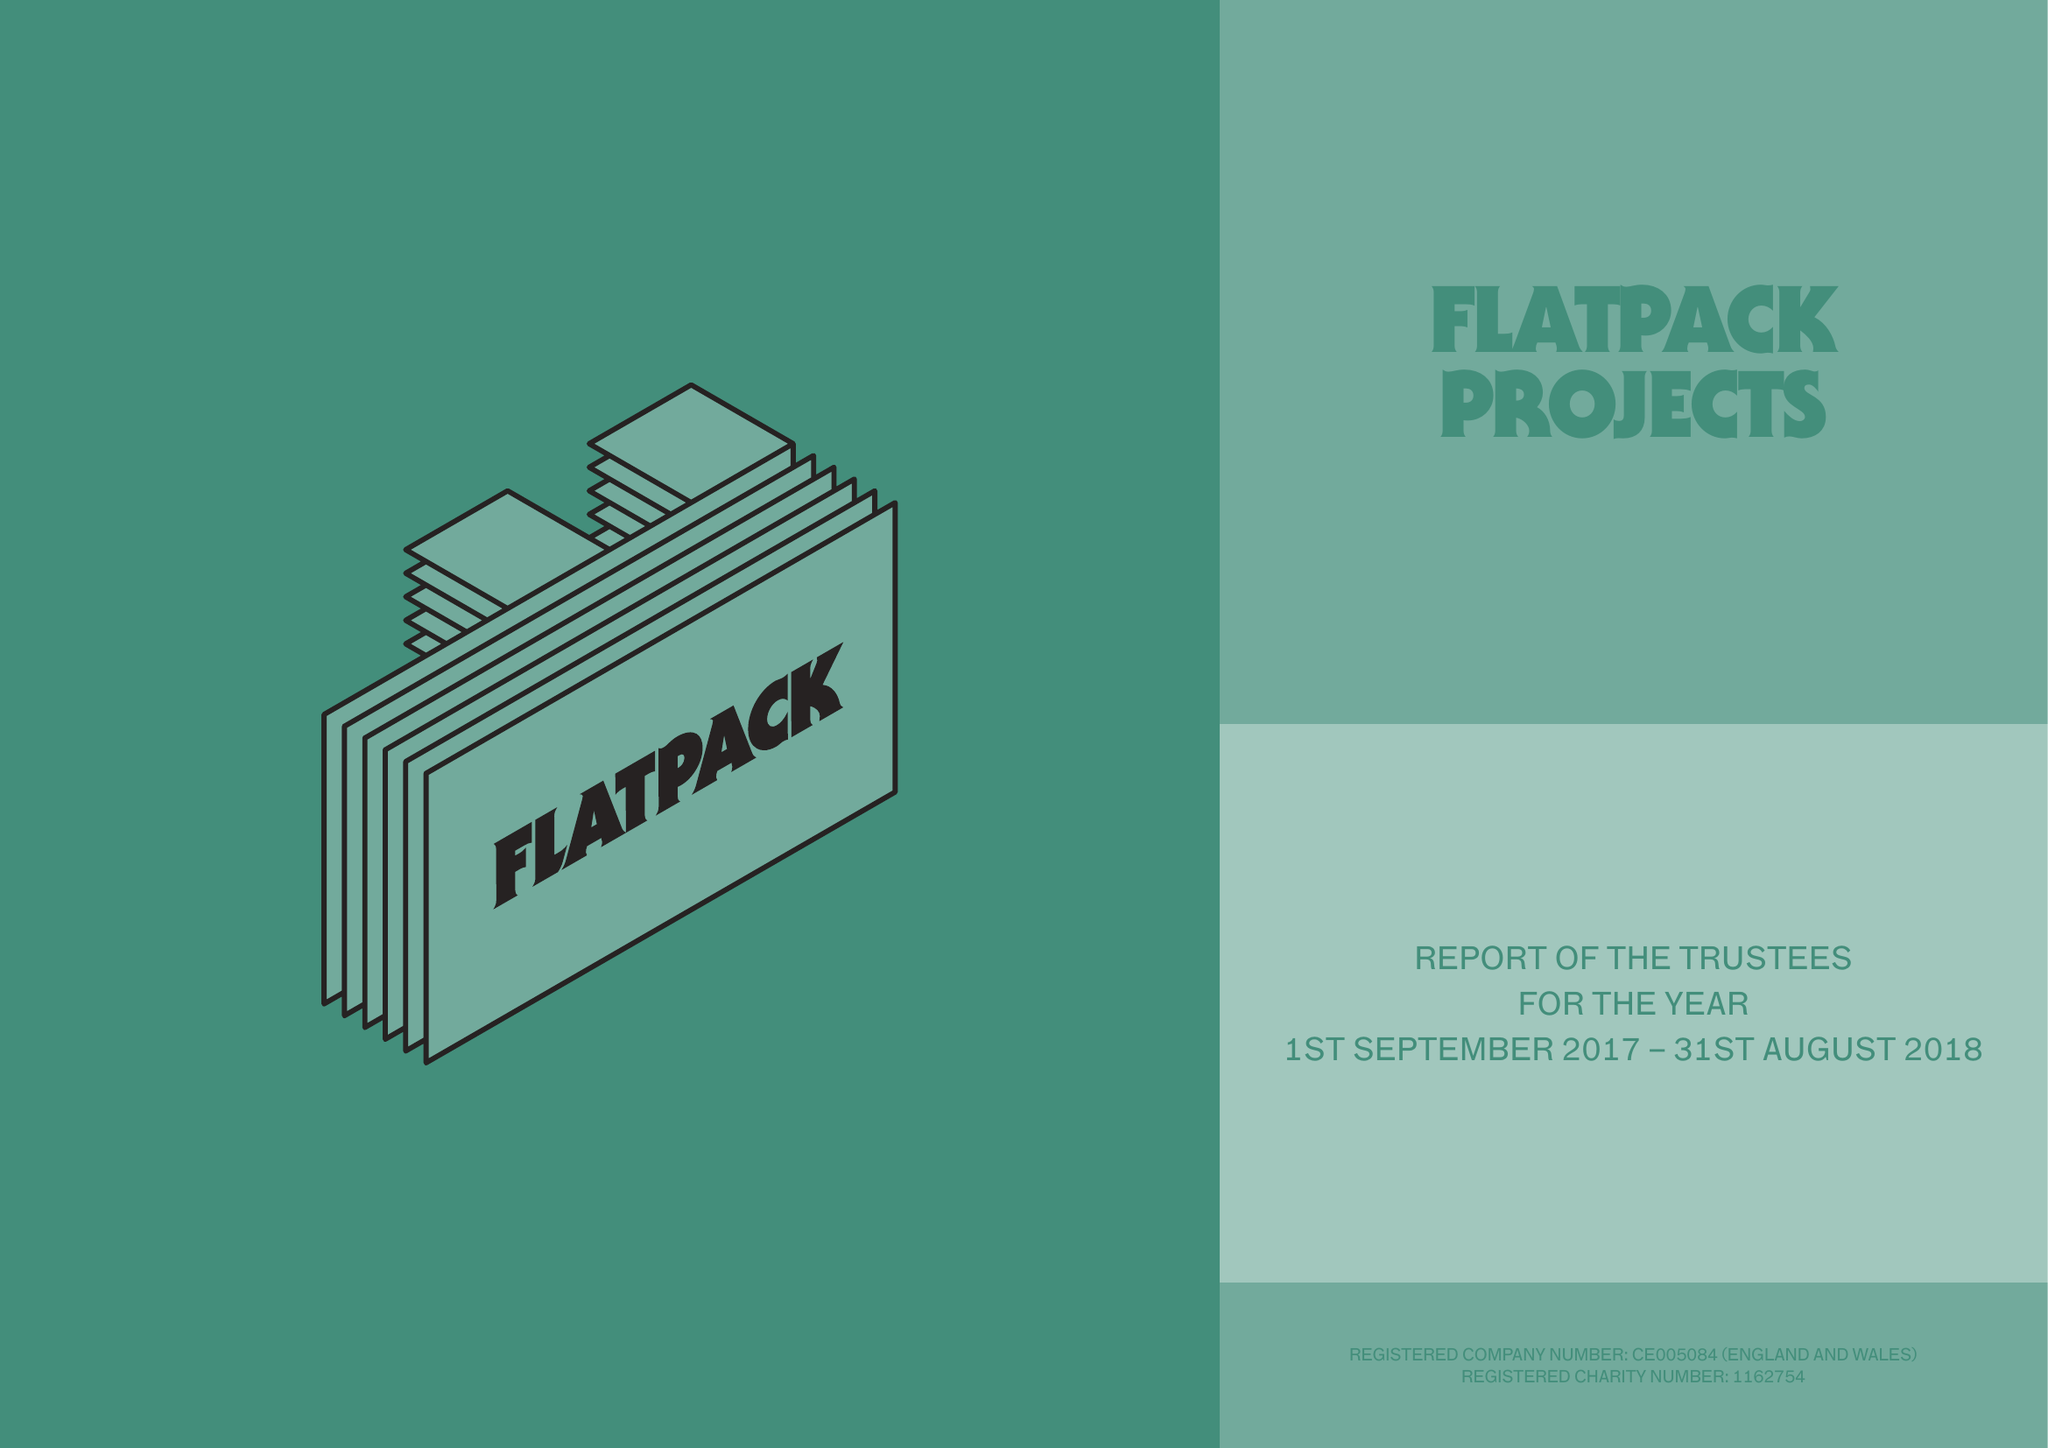What is the value for the report_date?
Answer the question using a single word or phrase. 2018-08-31 